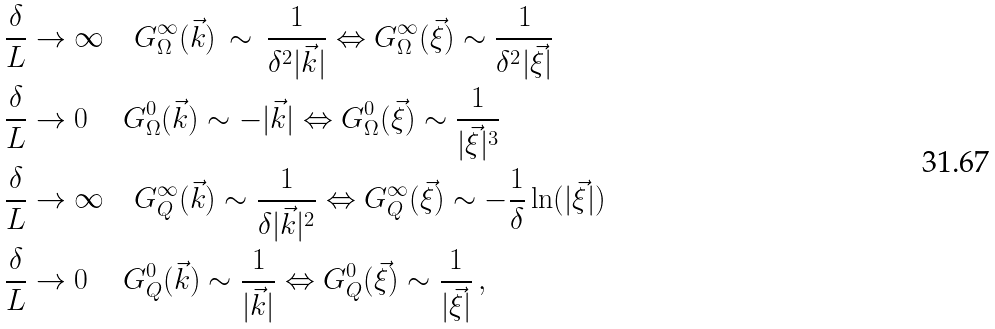<formula> <loc_0><loc_0><loc_500><loc_500>& \frac { \delta } { L } \rightarrow \infty \quad G _ { \Omega } ^ { \infty } ( \vec { k } ) \, \sim \, \frac { 1 } { \delta ^ { 2 } | \vec { k } | } \Leftrightarrow G _ { \Omega } ^ { \infty } ( \vec { \xi } ) \sim \frac { 1 } { \delta ^ { 2 } | \vec { \xi } | } \\ & \frac { \delta } { L } \rightarrow 0 \, \quad G _ { \Omega } ^ { 0 } ( \vec { k } ) \sim - | \vec { k } | \Leftrightarrow G _ { \Omega } ^ { 0 } ( \vec { \xi } ) \sim \frac { 1 } { | \vec { \xi } | ^ { 3 } } \\ & \frac { \delta } { L } \rightarrow \infty \quad G _ { Q } ^ { \infty } ( \vec { k } ) \sim \frac { 1 } { \delta | \vec { k } | ^ { 2 } } \Leftrightarrow G _ { Q } ^ { \infty } ( \vec { \xi } ) \sim - \frac { 1 } { \delta } \ln ( | \vec { \xi } | ) \\ & \frac { \delta } { L } \rightarrow 0 \, \quad G _ { Q } ^ { 0 } ( \vec { k } ) \sim \frac { 1 } { | \vec { k } | } \Leftrightarrow G _ { Q } ^ { 0 } ( \vec { \xi } ) \sim \frac { 1 } { | \vec { \xi } | } \, ,</formula> 